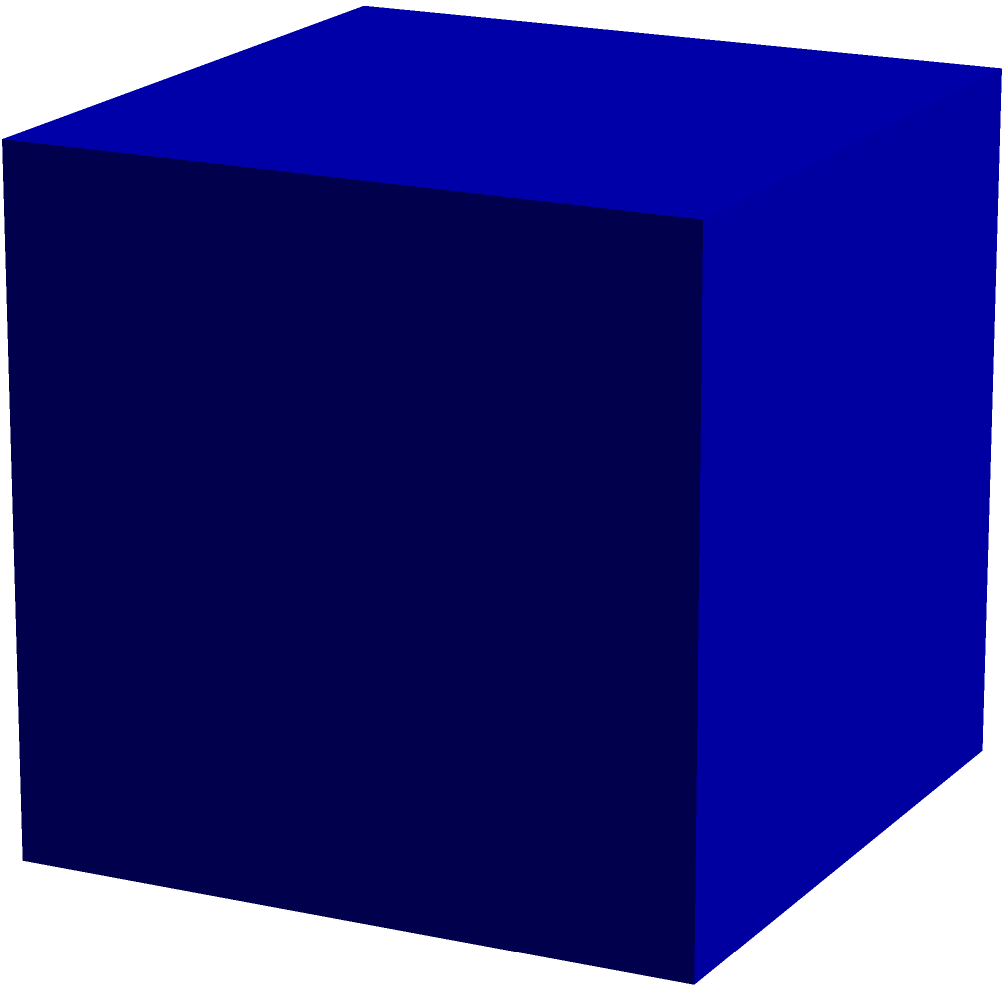As a therapist focusing on improving pianists' motor skills, you might use spatial reasoning exercises. Consider a cube with side length 1 unit, cut by a plane passing through the midpoints of edges EF, GH, and AD as shown in the figure. What is the shape of the resulting cross-section, and what is its area? Let's approach this step-by-step:

1) First, we need to identify the shape of the cross-section. The plane passes through the midpoints of three edges of the cube that form a right angle. This results in a triangle.

2) To find the area of this triangle, we need to determine its sides:

   a) Side PQ: This is parallel to edge AD and has the same length, which is 1 unit.
   
   b) Side QR: This is the diagonal of face ADHE. We can calculate its length using the Pythagorean theorem:
      $QR^2 = 1^2 + 1^2 = 2$
      $QR = \sqrt{2}$
   
   c) Side PR: This is the diagonal of face ABFE. Its length is also $\sqrt{2}$.

3) Now we have a right-angled triangle with hypotenuse 1 and other sides $\sqrt{2}$.

4) To calculate the area, we can use the formula: Area = $\frac{1}{2} \times base \times height$

5) We can choose either $\sqrt{2}$ side as the base. The height will then be the other $\sqrt{2}$ side.

6) Therefore, the area is:
   Area = $\frac{1}{2} \times \sqrt{2} \times \sqrt{2} = 1$ square unit

This spatial reasoning exercise can help pianists visualize complex shapes and improve their understanding of three-dimensional space, which can translate to better hand positioning and movement on the piano.
Answer: Right-angled isosceles triangle; Area = 1 square unit 